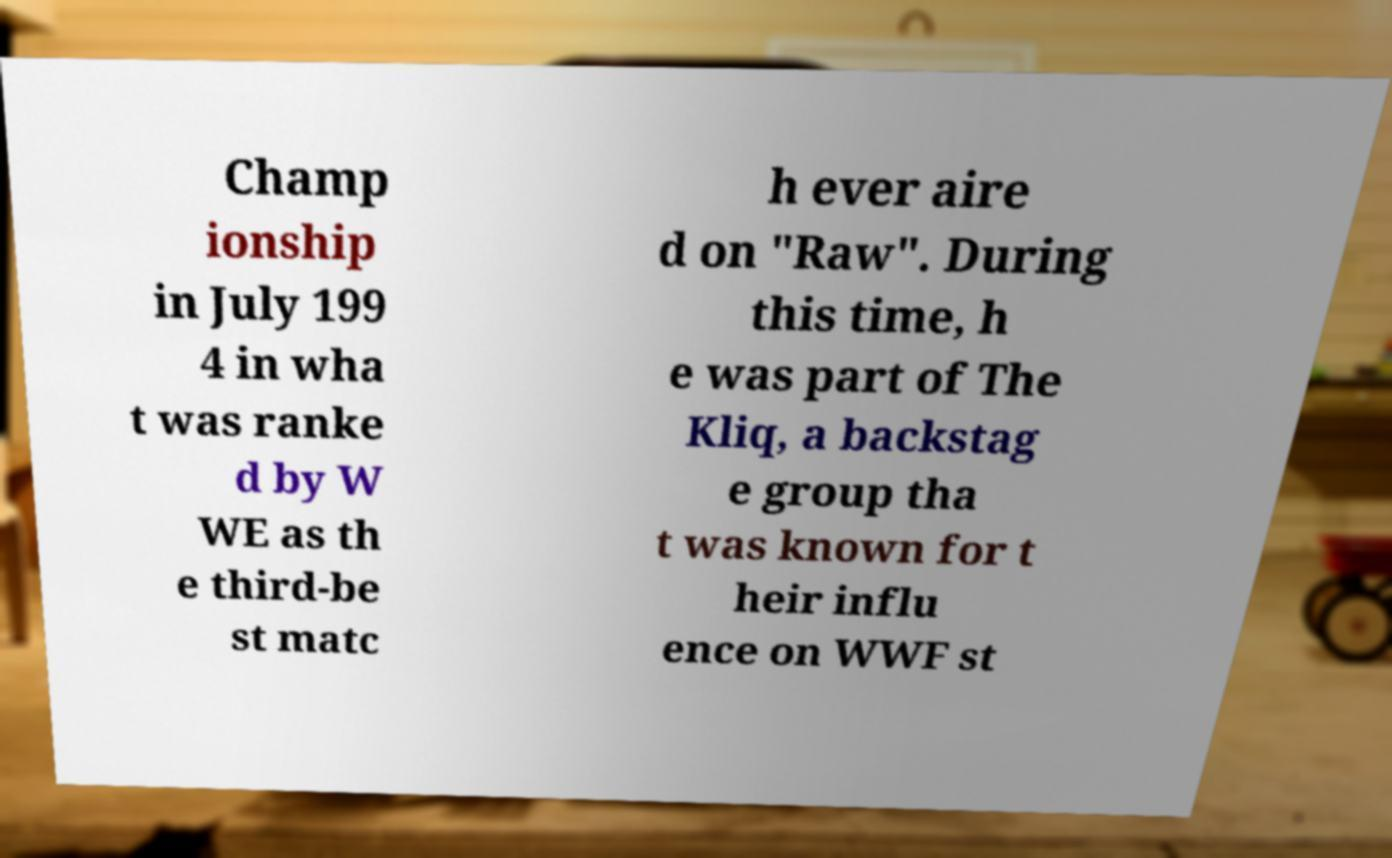I need the written content from this picture converted into text. Can you do that? Champ ionship in July 199 4 in wha t was ranke d by W WE as th e third-be st matc h ever aire d on "Raw". During this time, h e was part of The Kliq, a backstag e group tha t was known for t heir influ ence on WWF st 